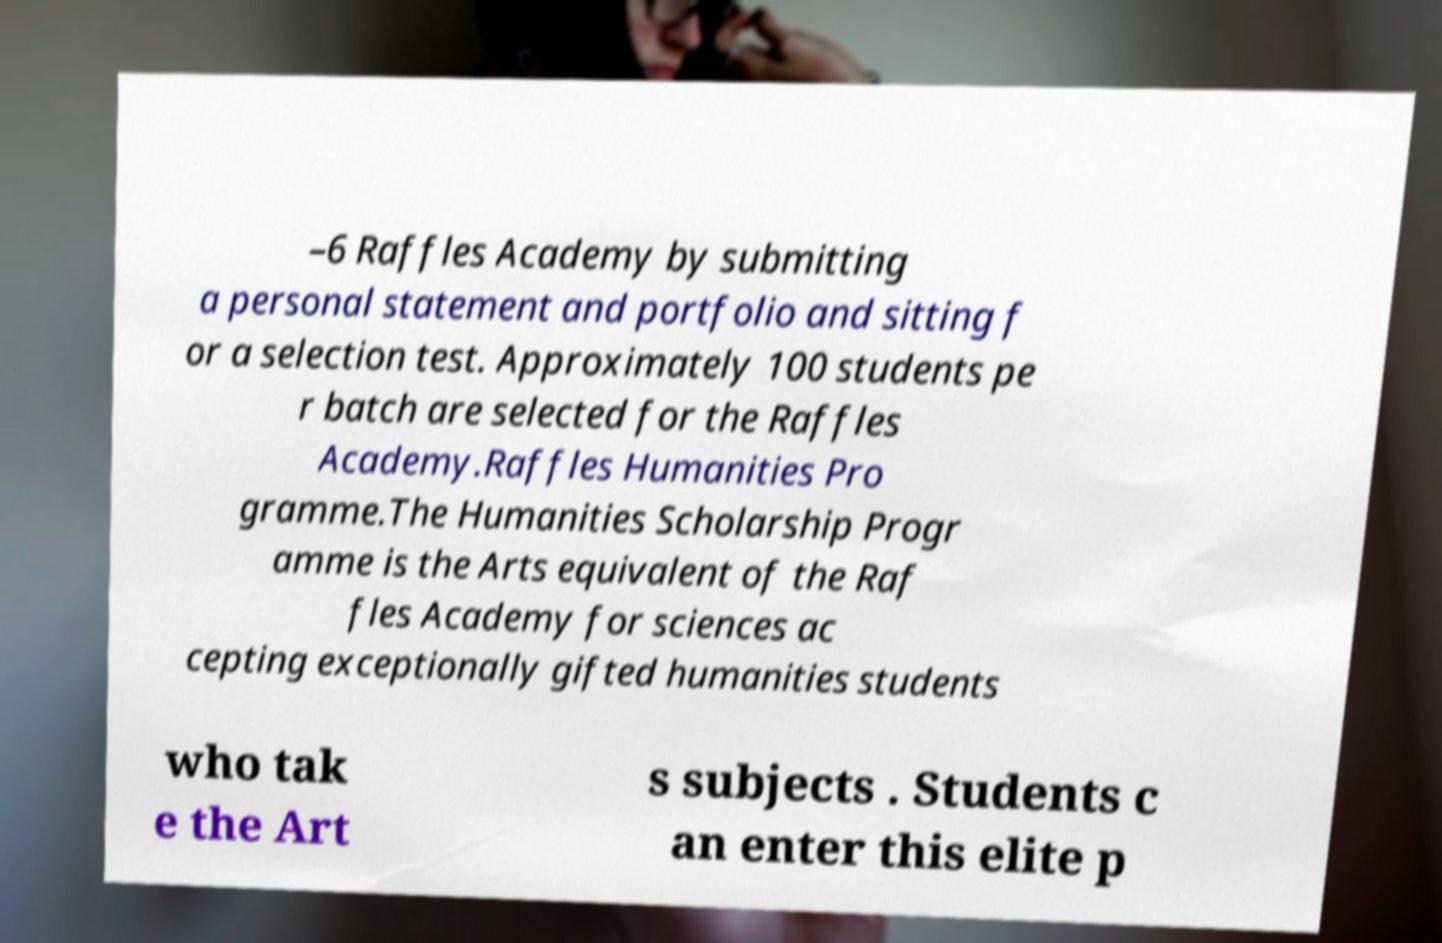Could you assist in decoding the text presented in this image and type it out clearly? –6 Raffles Academy by submitting a personal statement and portfolio and sitting f or a selection test. Approximately 100 students pe r batch are selected for the Raffles Academy.Raffles Humanities Pro gramme.The Humanities Scholarship Progr amme is the Arts equivalent of the Raf fles Academy for sciences ac cepting exceptionally gifted humanities students who tak e the Art s subjects . Students c an enter this elite p 